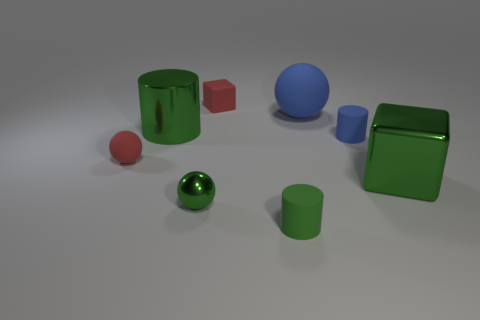Add 2 small yellow metallic balls. How many objects exist? 10 Subtract all cylinders. How many objects are left? 5 Add 1 tiny green metal balls. How many tiny green metal balls are left? 2 Add 4 small objects. How many small objects exist? 9 Subtract 0 brown cubes. How many objects are left? 8 Subtract all purple rubber cylinders. Subtract all tiny cylinders. How many objects are left? 6 